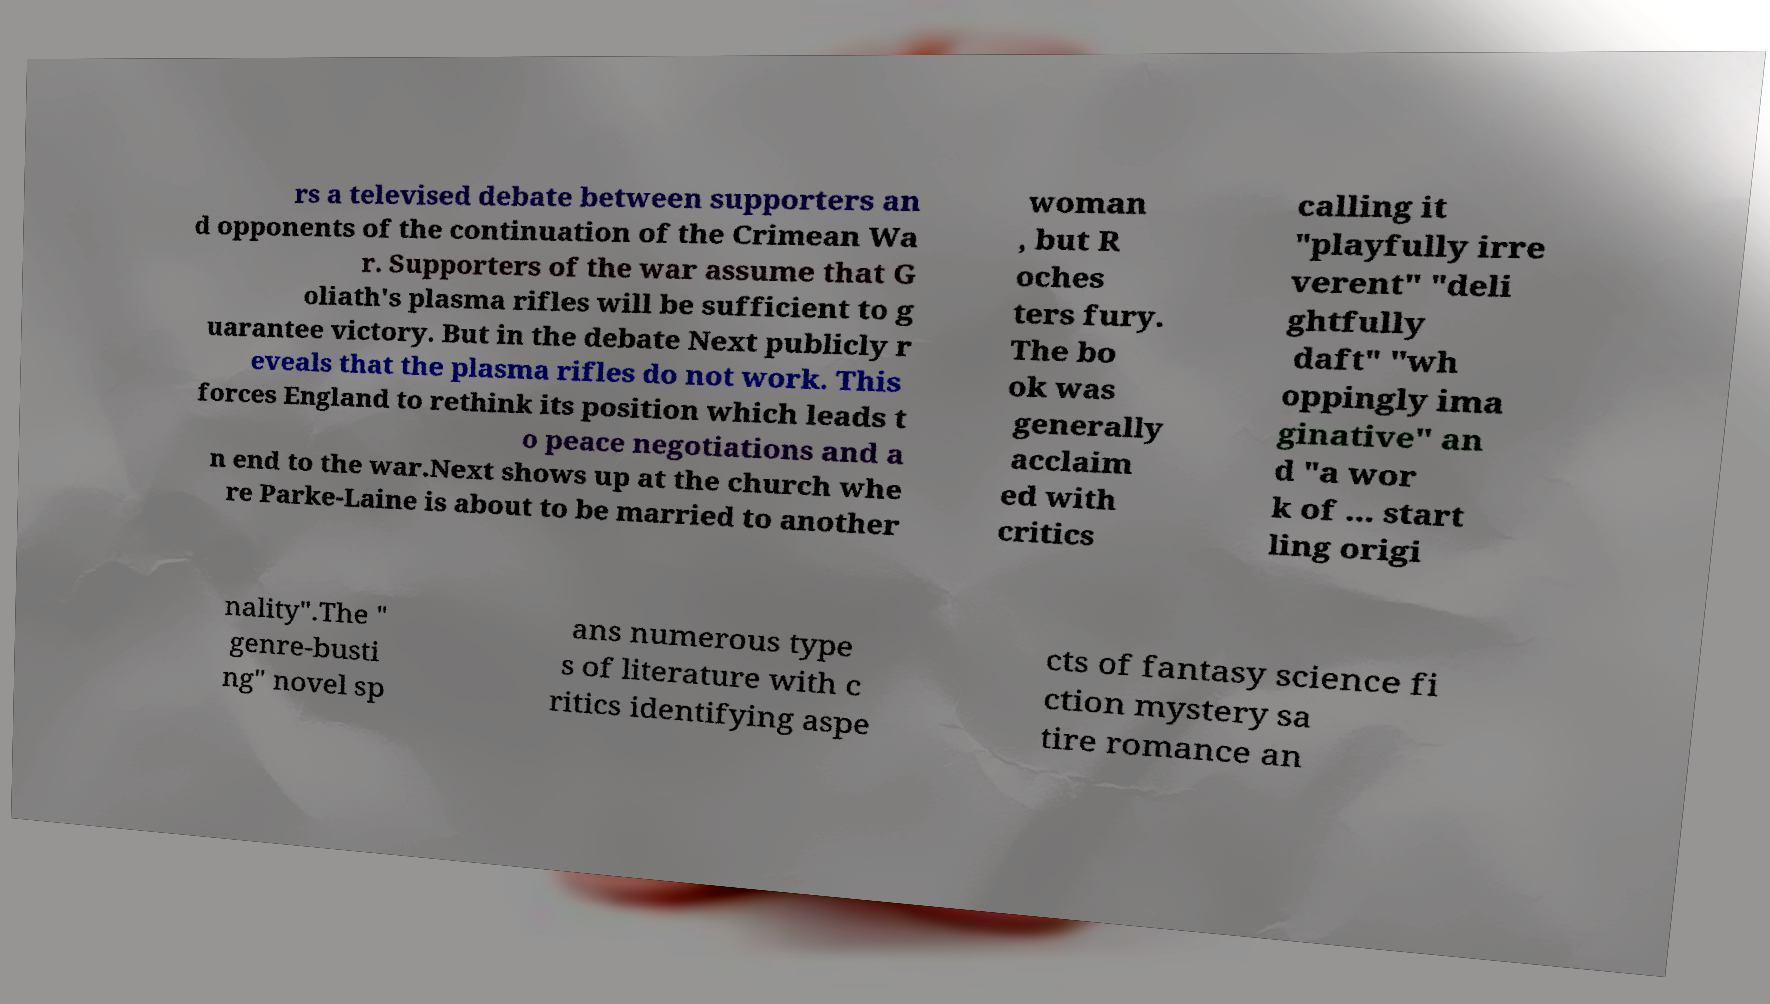Please read and relay the text visible in this image. What does it say? rs a televised debate between supporters an d opponents of the continuation of the Crimean Wa r. Supporters of the war assume that G oliath's plasma rifles will be sufficient to g uarantee victory. But in the debate Next publicly r eveals that the plasma rifles do not work. This forces England to rethink its position which leads t o peace negotiations and a n end to the war.Next shows up at the church whe re Parke-Laine is about to be married to another woman , but R oches ters fury. The bo ok was generally acclaim ed with critics calling it "playfully irre verent" "deli ghtfully daft" "wh oppingly ima ginative" an d "a wor k of ... start ling origi nality".The " genre-busti ng" novel sp ans numerous type s of literature with c ritics identifying aspe cts of fantasy science fi ction mystery sa tire romance an 